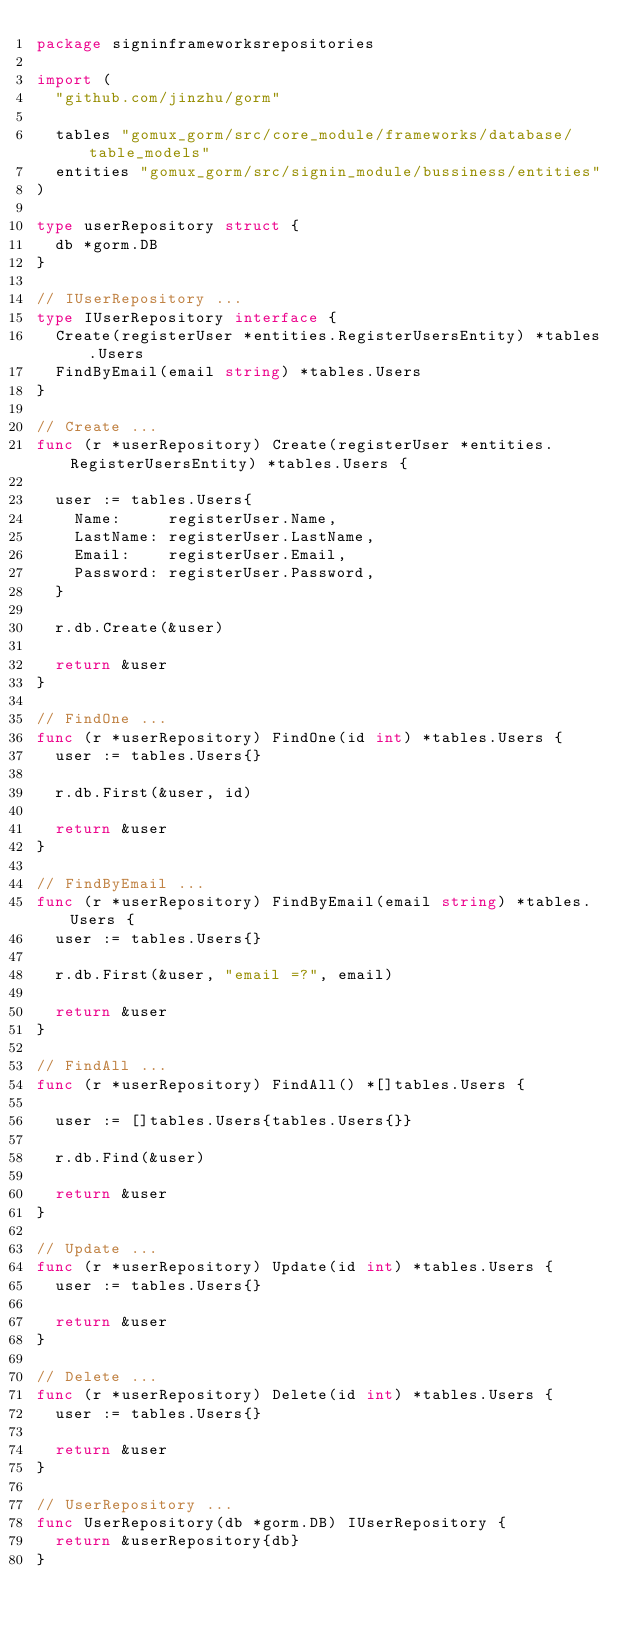<code> <loc_0><loc_0><loc_500><loc_500><_Go_>package signinframeworksrepositories

import (
	"github.com/jinzhu/gorm"

	tables "gomux_gorm/src/core_module/frameworks/database/table_models"
	entities "gomux_gorm/src/signin_module/bussiness/entities"
)

type userRepository struct {
	db *gorm.DB
}

// IUserRepository ...
type IUserRepository interface {
	Create(registerUser *entities.RegisterUsersEntity) *tables.Users
	FindByEmail(email string) *tables.Users
}

// Create ...
func (r *userRepository) Create(registerUser *entities.RegisterUsersEntity) *tables.Users {

	user := tables.Users{
		Name:     registerUser.Name,
		LastName: registerUser.LastName,
		Email:    registerUser.Email,
		Password: registerUser.Password,
	}

	r.db.Create(&user)

	return &user
}

// FindOne ...
func (r *userRepository) FindOne(id int) *tables.Users {
	user := tables.Users{}

	r.db.First(&user, id)

	return &user
}

// FindByEmail ...
func (r *userRepository) FindByEmail(email string) *tables.Users {
	user := tables.Users{}

	r.db.First(&user, "email =?", email)

	return &user
}

// FindAll ...
func (r *userRepository) FindAll() *[]tables.Users {

	user := []tables.Users{tables.Users{}}

	r.db.Find(&user)

	return &user
}

// Update ...
func (r *userRepository) Update(id int) *tables.Users {
	user := tables.Users{}

	return &user
}

// Delete ...
func (r *userRepository) Delete(id int) *tables.Users {
	user := tables.Users{}

	return &user
}

// UserRepository ...
func UserRepository(db *gorm.DB) IUserRepository {
	return &userRepository{db}
}
</code> 